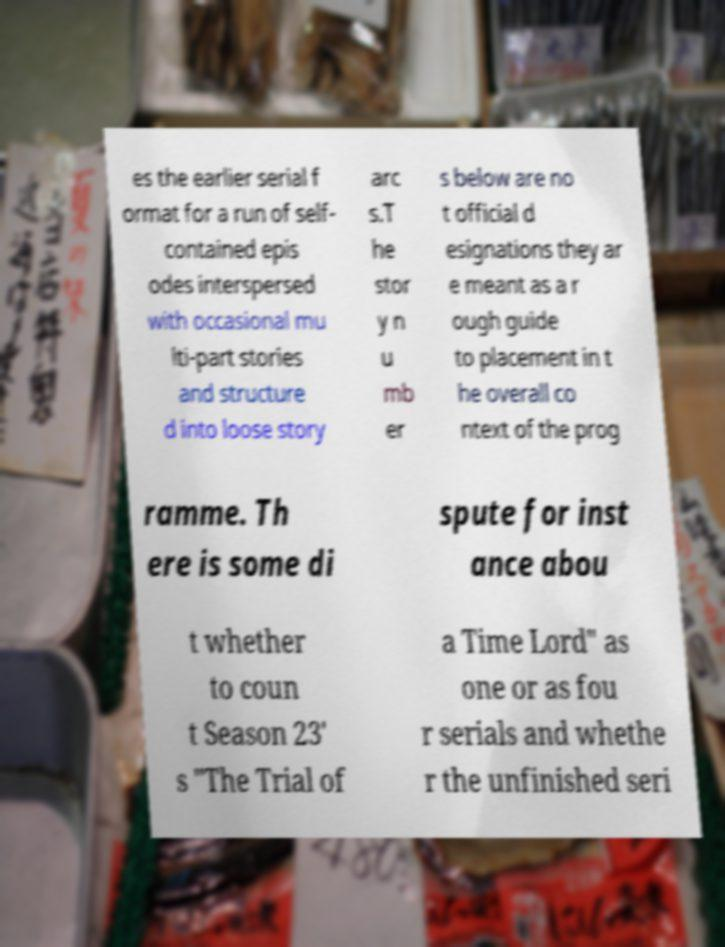There's text embedded in this image that I need extracted. Can you transcribe it verbatim? es the earlier serial f ormat for a run of self- contained epis odes interspersed with occasional mu lti-part stories and structure d into loose story arc s.T he stor y n u mb er s below are no t official d esignations they ar e meant as a r ough guide to placement in t he overall co ntext of the prog ramme. Th ere is some di spute for inst ance abou t whether to coun t Season 23' s "The Trial of a Time Lord" as one or as fou r serials and whethe r the unfinished seri 